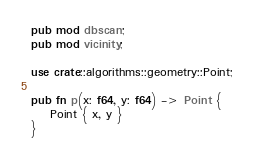<code> <loc_0><loc_0><loc_500><loc_500><_Rust_>pub mod dbscan;
pub mod vicinity;

use crate::algorithms::geometry::Point;

pub fn p(x: f64, y: f64) -> Point {
    Point { x, y }
}
</code> 